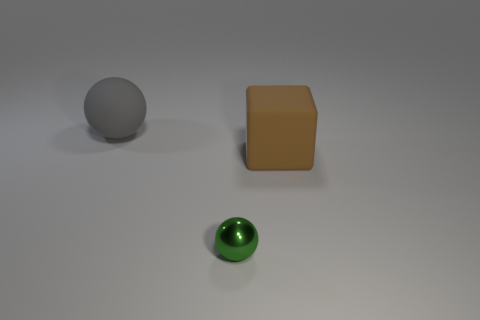Add 2 tiny yellow matte objects. How many objects exist? 5 Add 3 matte balls. How many matte balls are left? 4 Add 2 small metal spheres. How many small metal spheres exist? 3 Subtract all gray spheres. How many spheres are left? 1 Subtract 0 brown balls. How many objects are left? 3 Subtract all spheres. How many objects are left? 1 Subtract all brown balls. Subtract all yellow blocks. How many balls are left? 2 Subtract all green blocks. How many gray spheres are left? 1 Subtract all rubber objects. Subtract all small balls. How many objects are left? 0 